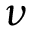Convert formula to latex. <formula><loc_0><loc_0><loc_500><loc_500>\nu</formula> 